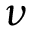Convert formula to latex. <formula><loc_0><loc_0><loc_500><loc_500>\nu</formula> 